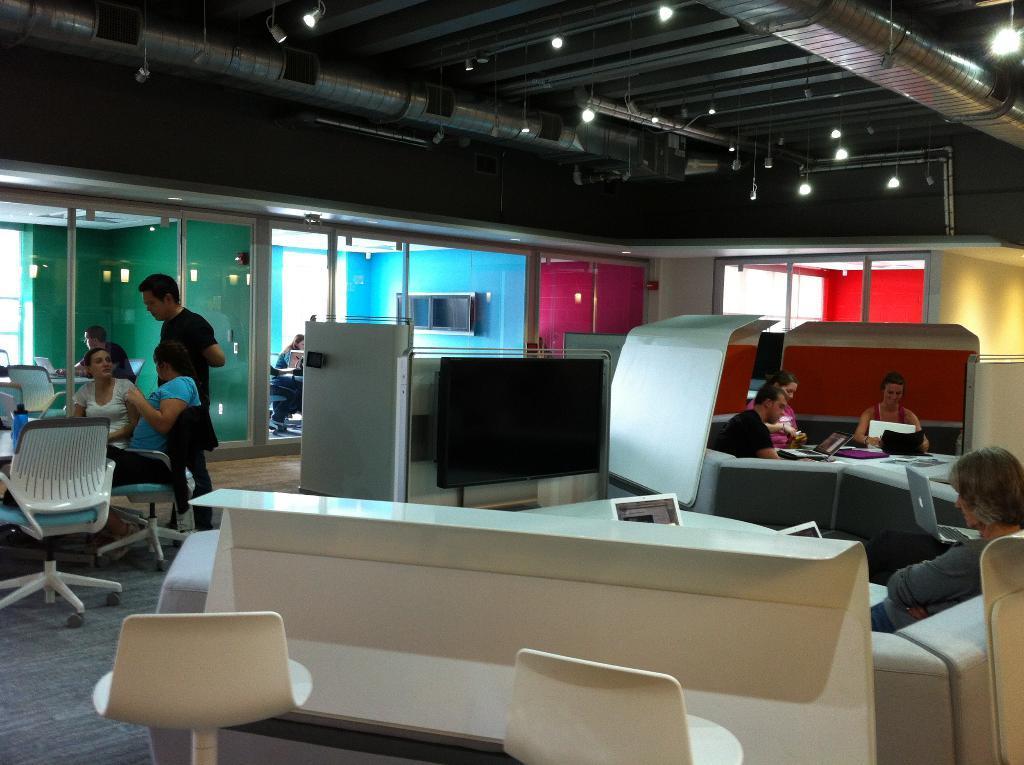In one or two sentences, can you explain what this image depicts? Few persons sitting. This person standing. We can see chairs and tables, sofa. On the top we can see lights. We can see television. On the background we can see wall. This is floor. 